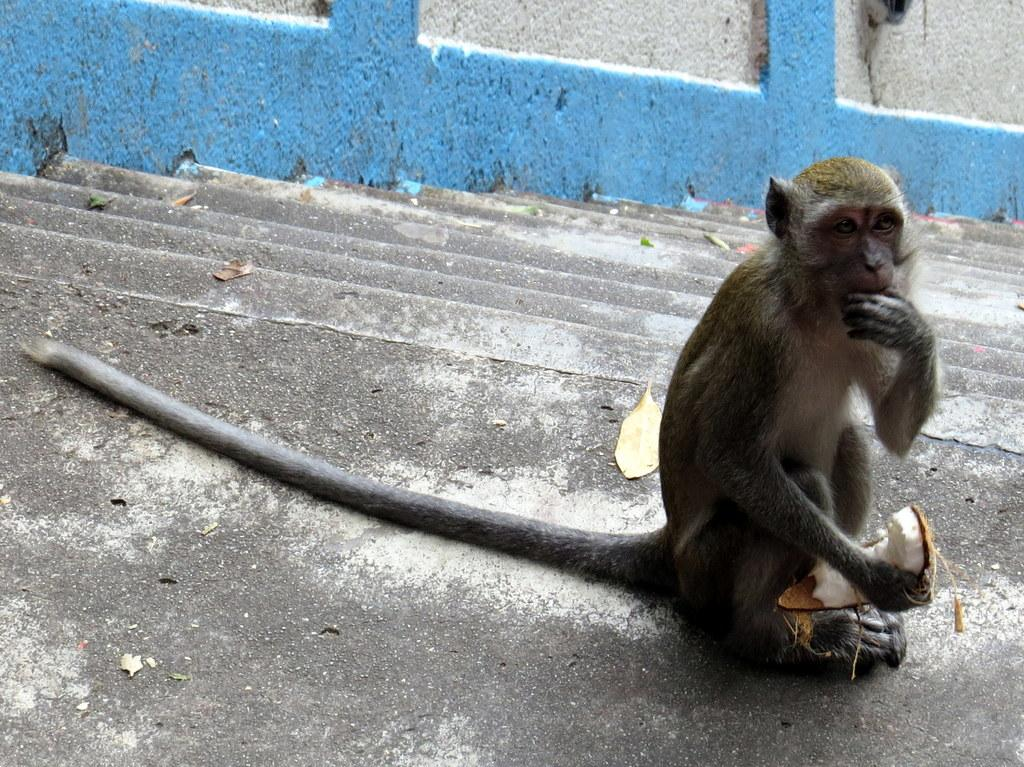What animal is present in the image? There is a monkey in the image. What is the monkey doing in the image? The monkey is sitting on the floor and holding a coconut in its hand. What architectural feature can be seen in the image? There are stairs visible in the image. What is the monkey's physical characteristic mentioned in the facts? The monkey has a long tail. What type of baseball equipment can be seen in the image? There is no baseball equipment present in the image. What is the monkey observing in the image? The facts provided do not mention the monkey observing anything in the image. 